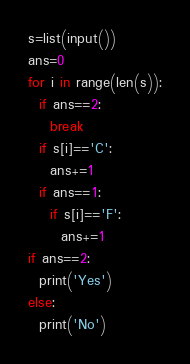<code> <loc_0><loc_0><loc_500><loc_500><_Python_>s=list(input())
ans=0
for i in range(len(s)):
  if ans==2:
    break
  if s[i]=='C':
    ans+=1
  if ans==1:
    if s[i]=='F':
      ans+=1
if ans==2:
  print('Yes')
else:
  print('No')</code> 